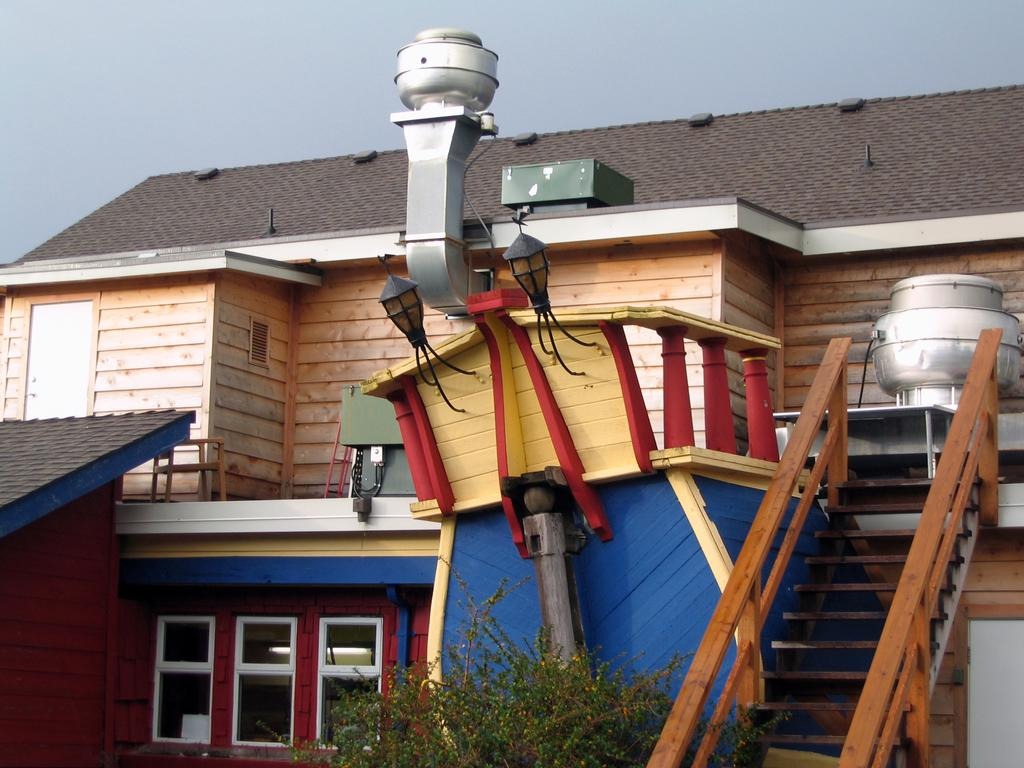What is the main subject of the image? There is a building at the center of the image. What is located in front of the building? There is a tree in front of the building. What can be seen in the background of the image? The sky is visible in the background of the image. How many police officers are visible in the image? There are no police officers present in the image. Can you see a cat climbing the tree in the image? There is no cat visible in the image. 